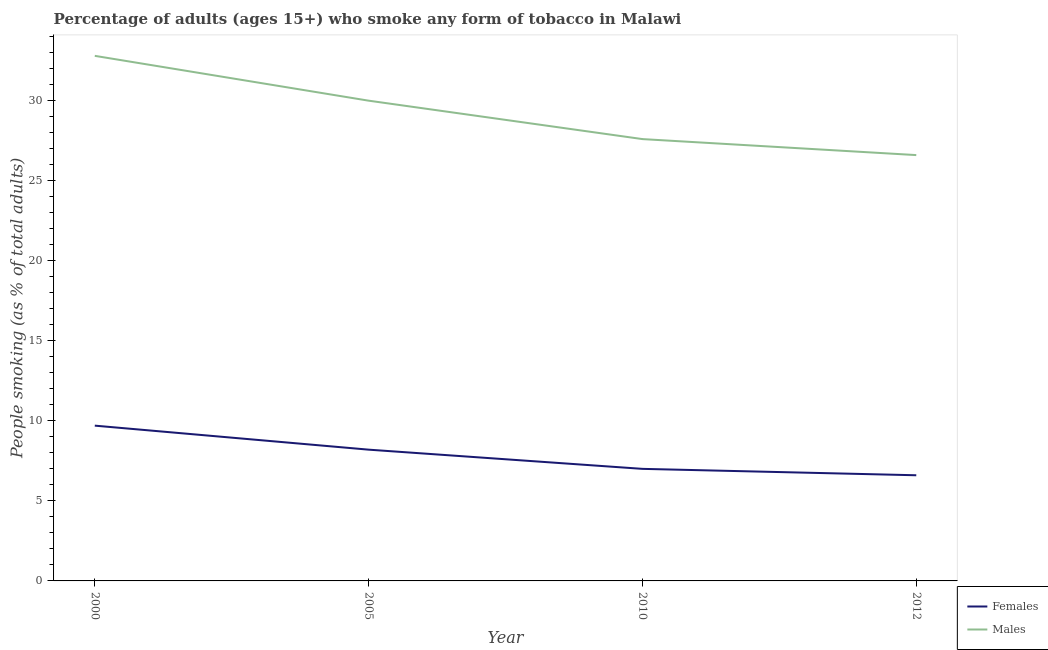Does the line corresponding to percentage of females who smoke intersect with the line corresponding to percentage of males who smoke?
Provide a succinct answer. No. Is the number of lines equal to the number of legend labels?
Offer a terse response. Yes. What is the percentage of males who smoke in 2000?
Ensure brevity in your answer.  32.8. Across all years, what is the minimum percentage of males who smoke?
Your answer should be very brief. 26.6. In which year was the percentage of males who smoke minimum?
Your answer should be very brief. 2012. What is the total percentage of females who smoke in the graph?
Make the answer very short. 31.5. What is the difference between the percentage of females who smoke in 2000 and that in 2010?
Offer a very short reply. 2.7. What is the difference between the percentage of females who smoke in 2010 and the percentage of males who smoke in 2000?
Ensure brevity in your answer.  -25.8. What is the average percentage of males who smoke per year?
Ensure brevity in your answer.  29.25. In the year 2010, what is the difference between the percentage of females who smoke and percentage of males who smoke?
Offer a terse response. -20.6. In how many years, is the percentage of females who smoke greater than 12 %?
Your answer should be very brief. 0. What is the ratio of the percentage of females who smoke in 2005 to that in 2012?
Offer a very short reply. 1.24. Is the percentage of males who smoke in 2010 less than that in 2012?
Provide a short and direct response. No. Is the difference between the percentage of males who smoke in 2000 and 2010 greater than the difference between the percentage of females who smoke in 2000 and 2010?
Provide a short and direct response. Yes. What is the difference between the highest and the second highest percentage of males who smoke?
Keep it short and to the point. 2.8. What is the difference between the highest and the lowest percentage of males who smoke?
Make the answer very short. 6.2. Does the percentage of males who smoke monotonically increase over the years?
Provide a succinct answer. No. Is the percentage of males who smoke strictly less than the percentage of females who smoke over the years?
Offer a terse response. No. How many lines are there?
Provide a short and direct response. 2. How many years are there in the graph?
Provide a short and direct response. 4. Does the graph contain any zero values?
Ensure brevity in your answer.  No. Does the graph contain grids?
Make the answer very short. No. Where does the legend appear in the graph?
Your response must be concise. Bottom right. How many legend labels are there?
Make the answer very short. 2. What is the title of the graph?
Keep it short and to the point. Percentage of adults (ages 15+) who smoke any form of tobacco in Malawi. Does "Nonresident" appear as one of the legend labels in the graph?
Offer a terse response. No. What is the label or title of the Y-axis?
Offer a very short reply. People smoking (as % of total adults). What is the People smoking (as % of total adults) of Females in 2000?
Your answer should be very brief. 9.7. What is the People smoking (as % of total adults) in Males in 2000?
Provide a short and direct response. 32.8. What is the People smoking (as % of total adults) of Females in 2005?
Keep it short and to the point. 8.2. What is the People smoking (as % of total adults) in Females in 2010?
Make the answer very short. 7. What is the People smoking (as % of total adults) in Males in 2010?
Keep it short and to the point. 27.6. What is the People smoking (as % of total adults) of Females in 2012?
Offer a terse response. 6.6. What is the People smoking (as % of total adults) of Males in 2012?
Keep it short and to the point. 26.6. Across all years, what is the maximum People smoking (as % of total adults) of Females?
Provide a short and direct response. 9.7. Across all years, what is the maximum People smoking (as % of total adults) of Males?
Offer a very short reply. 32.8. Across all years, what is the minimum People smoking (as % of total adults) in Males?
Keep it short and to the point. 26.6. What is the total People smoking (as % of total adults) of Females in the graph?
Provide a short and direct response. 31.5. What is the total People smoking (as % of total adults) of Males in the graph?
Make the answer very short. 117. What is the difference between the People smoking (as % of total adults) of Females in 2000 and that in 2010?
Keep it short and to the point. 2.7. What is the difference between the People smoking (as % of total adults) in Males in 2000 and that in 2010?
Give a very brief answer. 5.2. What is the difference between the People smoking (as % of total adults) in Females in 2000 and that in 2012?
Ensure brevity in your answer.  3.1. What is the difference between the People smoking (as % of total adults) in Females in 2005 and that in 2010?
Provide a short and direct response. 1.2. What is the difference between the People smoking (as % of total adults) in Males in 2005 and that in 2010?
Your answer should be very brief. 2.4. What is the difference between the People smoking (as % of total adults) in Males in 2005 and that in 2012?
Give a very brief answer. 3.4. What is the difference between the People smoking (as % of total adults) in Females in 2010 and that in 2012?
Make the answer very short. 0.4. What is the difference between the People smoking (as % of total adults) of Males in 2010 and that in 2012?
Keep it short and to the point. 1. What is the difference between the People smoking (as % of total adults) in Females in 2000 and the People smoking (as % of total adults) in Males in 2005?
Your answer should be compact. -20.3. What is the difference between the People smoking (as % of total adults) of Females in 2000 and the People smoking (as % of total adults) of Males in 2010?
Provide a succinct answer. -17.9. What is the difference between the People smoking (as % of total adults) in Females in 2000 and the People smoking (as % of total adults) in Males in 2012?
Your answer should be very brief. -16.9. What is the difference between the People smoking (as % of total adults) of Females in 2005 and the People smoking (as % of total adults) of Males in 2010?
Offer a very short reply. -19.4. What is the difference between the People smoking (as % of total adults) of Females in 2005 and the People smoking (as % of total adults) of Males in 2012?
Provide a short and direct response. -18.4. What is the difference between the People smoking (as % of total adults) in Females in 2010 and the People smoking (as % of total adults) in Males in 2012?
Provide a short and direct response. -19.6. What is the average People smoking (as % of total adults) of Females per year?
Offer a terse response. 7.88. What is the average People smoking (as % of total adults) of Males per year?
Make the answer very short. 29.25. In the year 2000, what is the difference between the People smoking (as % of total adults) of Females and People smoking (as % of total adults) of Males?
Offer a terse response. -23.1. In the year 2005, what is the difference between the People smoking (as % of total adults) in Females and People smoking (as % of total adults) in Males?
Offer a terse response. -21.8. In the year 2010, what is the difference between the People smoking (as % of total adults) of Females and People smoking (as % of total adults) of Males?
Offer a very short reply. -20.6. In the year 2012, what is the difference between the People smoking (as % of total adults) of Females and People smoking (as % of total adults) of Males?
Your answer should be compact. -20. What is the ratio of the People smoking (as % of total adults) of Females in 2000 to that in 2005?
Your answer should be compact. 1.18. What is the ratio of the People smoking (as % of total adults) in Males in 2000 to that in 2005?
Offer a very short reply. 1.09. What is the ratio of the People smoking (as % of total adults) in Females in 2000 to that in 2010?
Make the answer very short. 1.39. What is the ratio of the People smoking (as % of total adults) of Males in 2000 to that in 2010?
Your answer should be very brief. 1.19. What is the ratio of the People smoking (as % of total adults) of Females in 2000 to that in 2012?
Give a very brief answer. 1.47. What is the ratio of the People smoking (as % of total adults) in Males in 2000 to that in 2012?
Ensure brevity in your answer.  1.23. What is the ratio of the People smoking (as % of total adults) in Females in 2005 to that in 2010?
Your answer should be compact. 1.17. What is the ratio of the People smoking (as % of total adults) of Males in 2005 to that in 2010?
Your response must be concise. 1.09. What is the ratio of the People smoking (as % of total adults) in Females in 2005 to that in 2012?
Provide a succinct answer. 1.24. What is the ratio of the People smoking (as % of total adults) in Males in 2005 to that in 2012?
Ensure brevity in your answer.  1.13. What is the ratio of the People smoking (as % of total adults) in Females in 2010 to that in 2012?
Ensure brevity in your answer.  1.06. What is the ratio of the People smoking (as % of total adults) of Males in 2010 to that in 2012?
Offer a terse response. 1.04. What is the difference between the highest and the second highest People smoking (as % of total adults) of Females?
Your answer should be very brief. 1.5. What is the difference between the highest and the second highest People smoking (as % of total adults) of Males?
Your answer should be very brief. 2.8. What is the difference between the highest and the lowest People smoking (as % of total adults) in Males?
Make the answer very short. 6.2. 